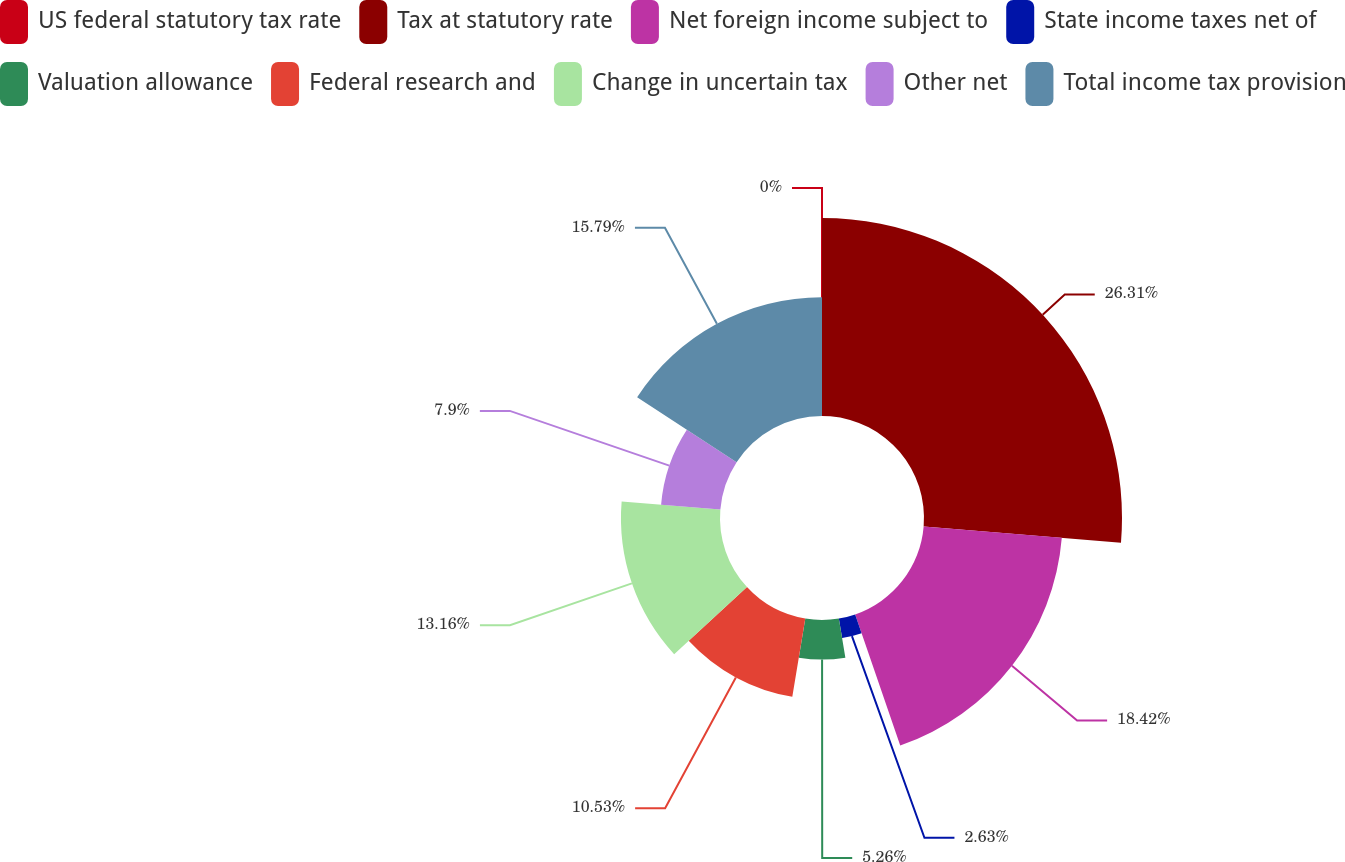<chart> <loc_0><loc_0><loc_500><loc_500><pie_chart><fcel>US federal statutory tax rate<fcel>Tax at statutory rate<fcel>Net foreign income subject to<fcel>State income taxes net of<fcel>Valuation allowance<fcel>Federal research and<fcel>Change in uncertain tax<fcel>Other net<fcel>Total income tax provision<nl><fcel>0.0%<fcel>26.31%<fcel>18.42%<fcel>2.63%<fcel>5.26%<fcel>10.53%<fcel>13.16%<fcel>7.9%<fcel>15.79%<nl></chart> 